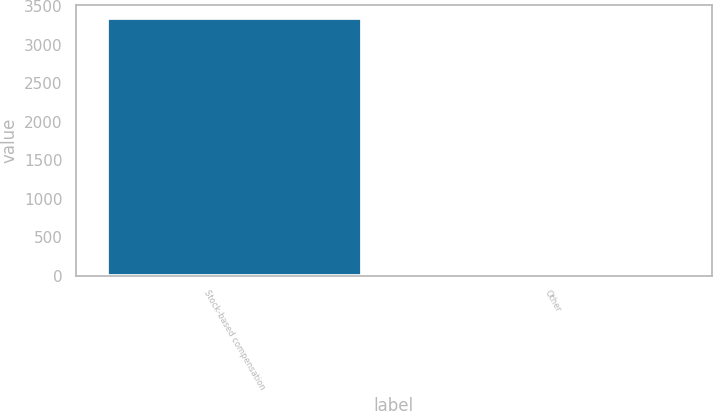Convert chart. <chart><loc_0><loc_0><loc_500><loc_500><bar_chart><fcel>Stock-based compensation<fcel>Other<nl><fcel>3343<fcel>15<nl></chart> 